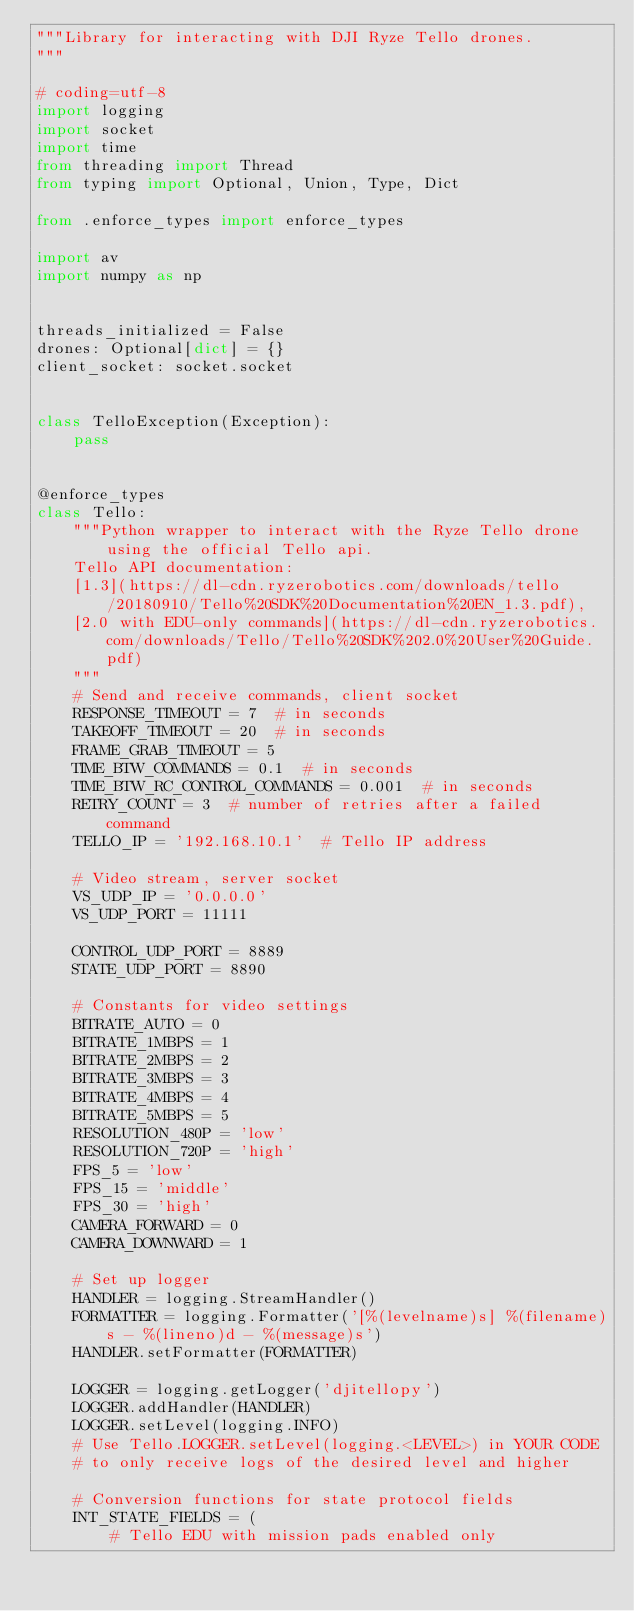<code> <loc_0><loc_0><loc_500><loc_500><_Python_>"""Library for interacting with DJI Ryze Tello drones.
"""

# coding=utf-8
import logging
import socket
import time
from threading import Thread
from typing import Optional, Union, Type, Dict

from .enforce_types import enforce_types

import av
import numpy as np


threads_initialized = False
drones: Optional[dict] = {}
client_socket: socket.socket


class TelloException(Exception):
    pass


@enforce_types
class Tello:
    """Python wrapper to interact with the Ryze Tello drone using the official Tello api.
    Tello API documentation:
    [1.3](https://dl-cdn.ryzerobotics.com/downloads/tello/20180910/Tello%20SDK%20Documentation%20EN_1.3.pdf),
    [2.0 with EDU-only commands](https://dl-cdn.ryzerobotics.com/downloads/Tello/Tello%20SDK%202.0%20User%20Guide.pdf)
    """
    # Send and receive commands, client socket
    RESPONSE_TIMEOUT = 7  # in seconds
    TAKEOFF_TIMEOUT = 20  # in seconds
    FRAME_GRAB_TIMEOUT = 5
    TIME_BTW_COMMANDS = 0.1  # in seconds
    TIME_BTW_RC_CONTROL_COMMANDS = 0.001  # in seconds
    RETRY_COUNT = 3  # number of retries after a failed command
    TELLO_IP = '192.168.10.1'  # Tello IP address

    # Video stream, server socket
    VS_UDP_IP = '0.0.0.0'
    VS_UDP_PORT = 11111

    CONTROL_UDP_PORT = 8889
    STATE_UDP_PORT = 8890

    # Constants for video settings
    BITRATE_AUTO = 0
    BITRATE_1MBPS = 1
    BITRATE_2MBPS = 2
    BITRATE_3MBPS = 3
    BITRATE_4MBPS = 4
    BITRATE_5MBPS = 5
    RESOLUTION_480P = 'low'
    RESOLUTION_720P = 'high'
    FPS_5 = 'low'
    FPS_15 = 'middle'
    FPS_30 = 'high'
    CAMERA_FORWARD = 0
    CAMERA_DOWNWARD = 1

    # Set up logger
    HANDLER = logging.StreamHandler()
    FORMATTER = logging.Formatter('[%(levelname)s] %(filename)s - %(lineno)d - %(message)s')
    HANDLER.setFormatter(FORMATTER)

    LOGGER = logging.getLogger('djitellopy')
    LOGGER.addHandler(HANDLER)
    LOGGER.setLevel(logging.INFO)
    # Use Tello.LOGGER.setLevel(logging.<LEVEL>) in YOUR CODE
    # to only receive logs of the desired level and higher

    # Conversion functions for state protocol fields
    INT_STATE_FIELDS = (
        # Tello EDU with mission pads enabled only</code> 